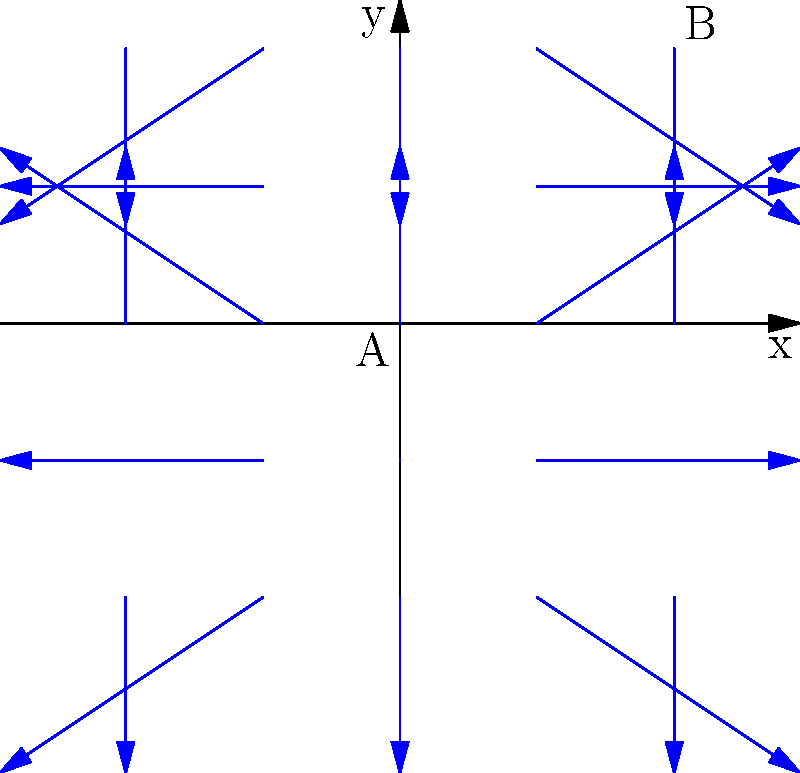Given the vector field represented by $\mathbf{F}(x,y) = (3\sin(x), 2\cos(y))$, estimate the wind direction and speed at point B $(π,π)$ compared to point A $(0,0)$. How would this information be useful for predicting potential flight delays? To solve this problem, let's follow these steps:

1) At point A $(0,0)$:
   $\mathbf{F}(0,0) = (3\sin(0), 2\cos(0)) = (0, 2)$
   Wind direction: Straight up
   Wind speed: $\sqrt{0^2 + 2^2} = 2$

2) At point B $(π,π)$:
   $\mathbf{F}(π,π) = (3\sin(π), 2\cos(π)) = (0, -2)$
   Wind direction: Straight down
   Wind speed: $\sqrt{0^2 + (-2)^2} = 2$

3) Comparing A and B:
   - Direction: Opposite (up at A, down at B)
   - Speed: Same magnitude (2 units)

4) Relevance to flight delay predictions:
   - Wind direction affects takeoff and landing procedures. Opposite winds at different locations could indicate turbulence or the need for route adjustments.
   - Consistent wind speeds suggest stable conditions, but the directional change could imply a weather front or system boundary.
   - This information would be crucial for:
     a) Calculating fuel consumption
     b) Estimating flight duration
     c) Assessing potential turbulence
     d) Planning for possible diversions or altered flight paths

5) As a travel agent using advanced algorithms, you could use this vector field data to:
   - Predict potential delays due to necessary route changes
   - Advise on the most stable flight times
   - Recommend alternative routes or departure/arrival times to minimize delay risks
Answer: Opposite directions, same speed; crucial for predicting route adjustments, turbulence, and potential delays. 